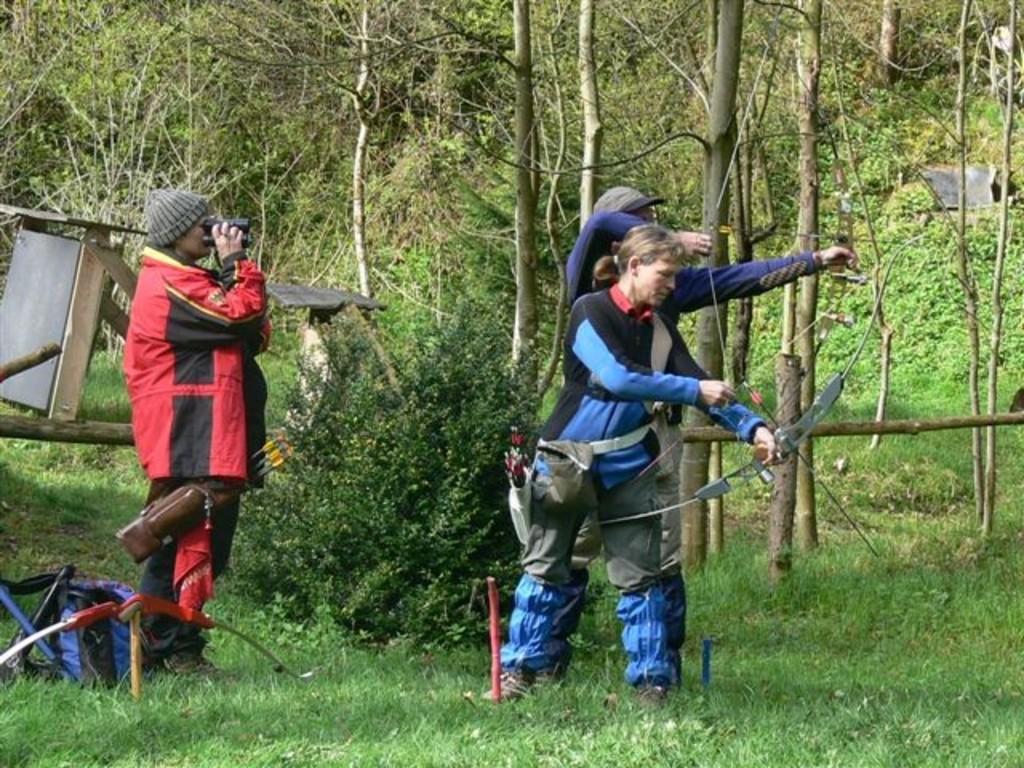Can you describe this image briefly? In this picture I can see three persons standing, there is a person standing and holding a binoculars, there are two persons standing and holding the bows and arrows, there are some objects and in the background there are trees. 